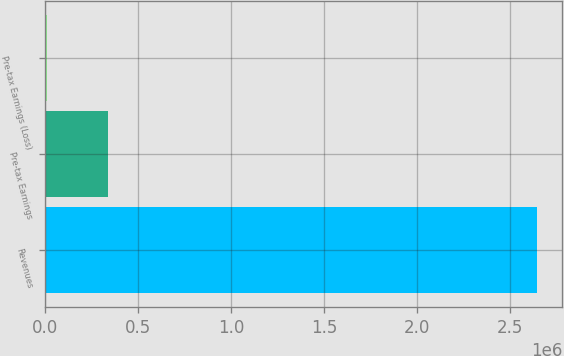Convert chart. <chart><loc_0><loc_0><loc_500><loc_500><bar_chart><fcel>Revenues<fcel>Pre-tax Earnings<fcel>Pre-tax Earnings (Loss)<nl><fcel>2.64558e+06<fcel>342066<fcel>11248<nl></chart> 